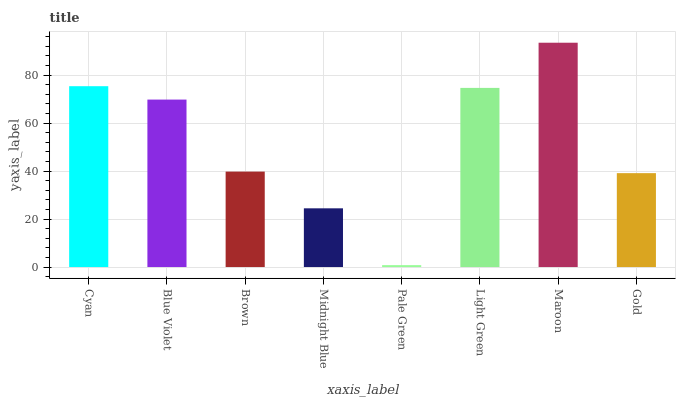Is Blue Violet the minimum?
Answer yes or no. No. Is Blue Violet the maximum?
Answer yes or no. No. Is Cyan greater than Blue Violet?
Answer yes or no. Yes. Is Blue Violet less than Cyan?
Answer yes or no. Yes. Is Blue Violet greater than Cyan?
Answer yes or no. No. Is Cyan less than Blue Violet?
Answer yes or no. No. Is Blue Violet the high median?
Answer yes or no. Yes. Is Brown the low median?
Answer yes or no. Yes. Is Midnight Blue the high median?
Answer yes or no. No. Is Maroon the low median?
Answer yes or no. No. 